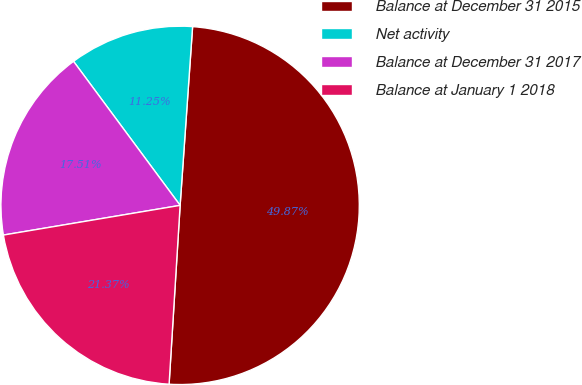Convert chart to OTSL. <chart><loc_0><loc_0><loc_500><loc_500><pie_chart><fcel>Balance at December 31 2015<fcel>Net activity<fcel>Balance at December 31 2017<fcel>Balance at January 1 2018<nl><fcel>49.87%<fcel>11.25%<fcel>17.51%<fcel>21.37%<nl></chart> 